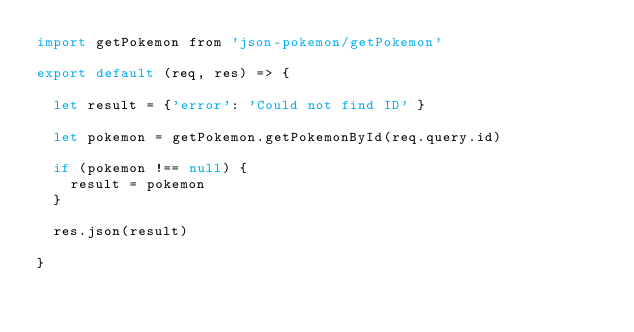Convert code to text. <code><loc_0><loc_0><loc_500><loc_500><_JavaScript_>import getPokemon from 'json-pokemon/getPokemon'

export default (req, res) => {

  let result = {'error': 'Could not find ID' }

  let pokemon = getPokemon.getPokemonById(req.query.id)

  if (pokemon !== null) {
    result = pokemon
  }

  res.json(result)

}</code> 